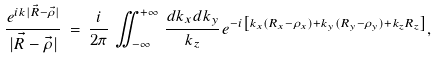<formula> <loc_0><loc_0><loc_500><loc_500>\frac { e ^ { i k | \vec { R } - \vec { \rho } | } } { | \vec { R } - \vec { \rho } | } \, = \, \frac { i } { 2 \pi } \, \iint _ { - \infty } ^ { + \infty } \, \frac { d k _ { x } d k _ { y } } { k _ { z } } e ^ { - i \left [ k _ { x } ( R _ { x } - \rho _ { x } ) + k _ { y } ( R _ { y } - \rho _ { y } ) + k _ { z } R _ { z } \right ] } ,</formula> 